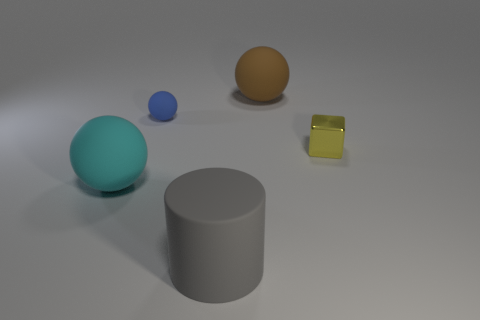There is a large sphere that is behind the yellow metal object; what is it made of?
Your answer should be compact. Rubber. What number of other gray objects have the same shape as the metal thing?
Offer a very short reply. 0. Are there the same number of cyan things and rubber spheres?
Offer a terse response. No. There is a small object left of the rubber thing on the right side of the matte cylinder; what is its material?
Keep it short and to the point. Rubber. Are there any tiny cylinders made of the same material as the yellow object?
Provide a short and direct response. No. The gray matte thing has what shape?
Ensure brevity in your answer.  Cylinder. What number of big cyan things are there?
Your answer should be compact. 1. The big matte sphere that is to the right of the big rubber sphere in front of the tiny cube is what color?
Keep it short and to the point. Brown. There is a rubber ball that is the same size as the metallic thing; what color is it?
Keep it short and to the point. Blue. Is there a rubber object that has the same color as the tiny matte ball?
Offer a terse response. No. 